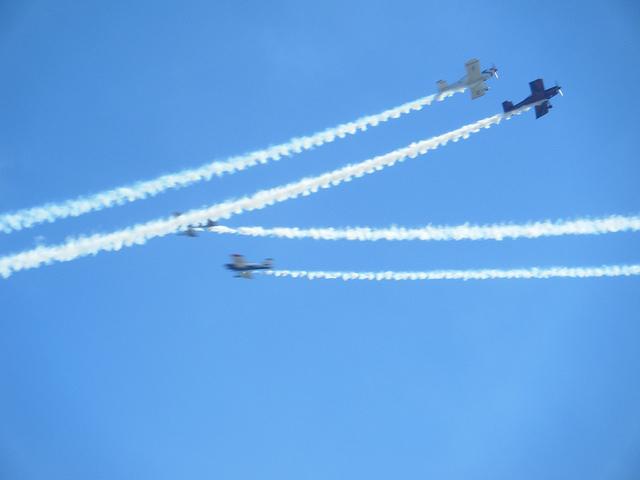Which direction are the planes on top of the picture flying towards?
Answer briefly. Right. Are all the planes flying in the same direction?
Be succinct. No. What is the weather like?
Answer briefly. Sunny. 